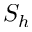Convert formula to latex. <formula><loc_0><loc_0><loc_500><loc_500>S _ { h }</formula> 